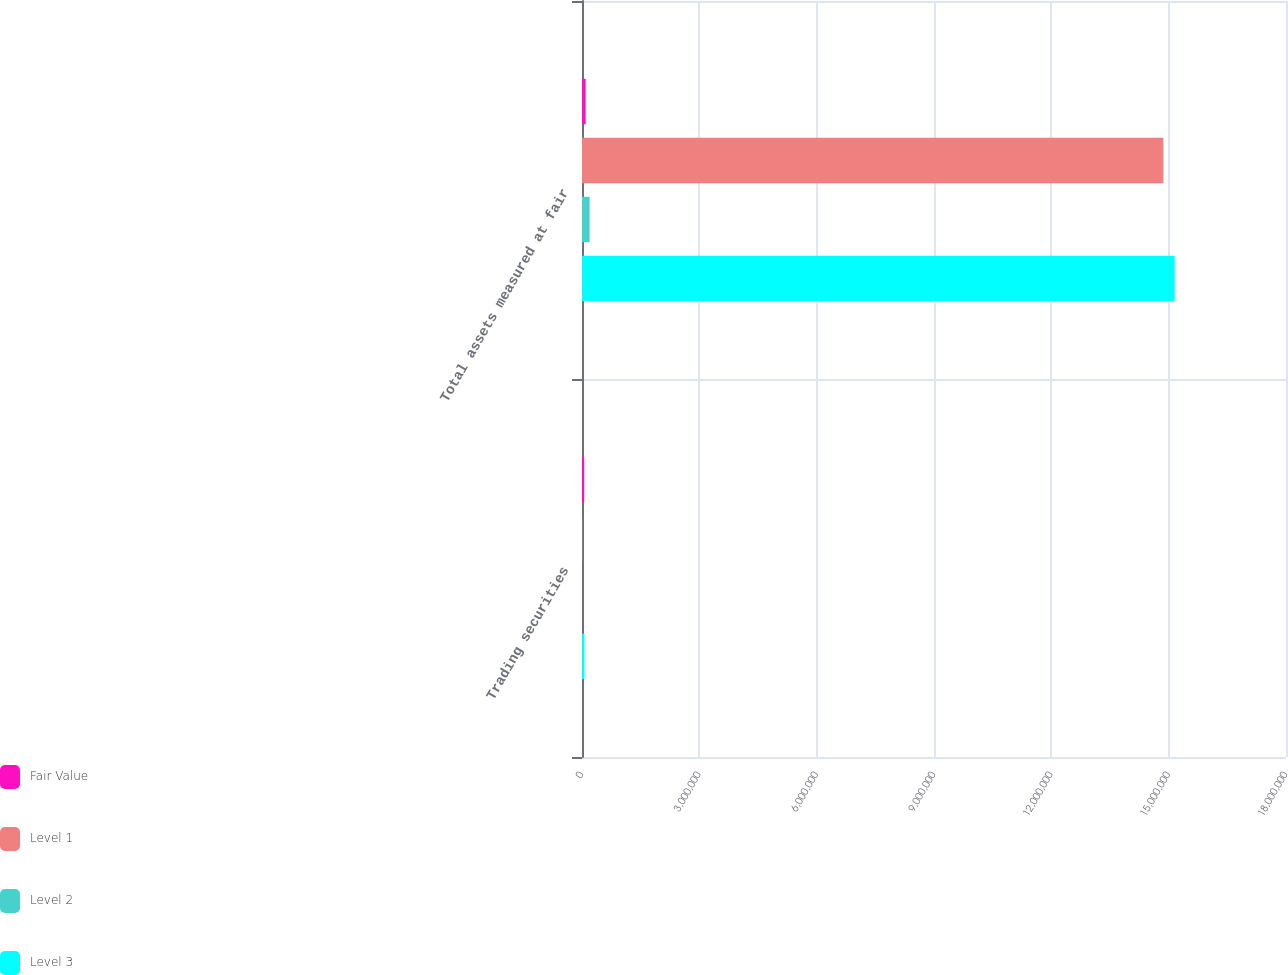<chart> <loc_0><loc_0><loc_500><loc_500><stacked_bar_chart><ecel><fcel>Trading securities<fcel>Total assets measured at fair<nl><fcel>Fair Value<fcel>55630<fcel>93630<nl><fcel>Level 1<fcel>5913<fcel>1.48653e+07<nl><fcel>Level 2<fcel>630<fcel>195850<nl><fcel>Level 3<fcel>62173<fcel>1.51548e+07<nl></chart> 